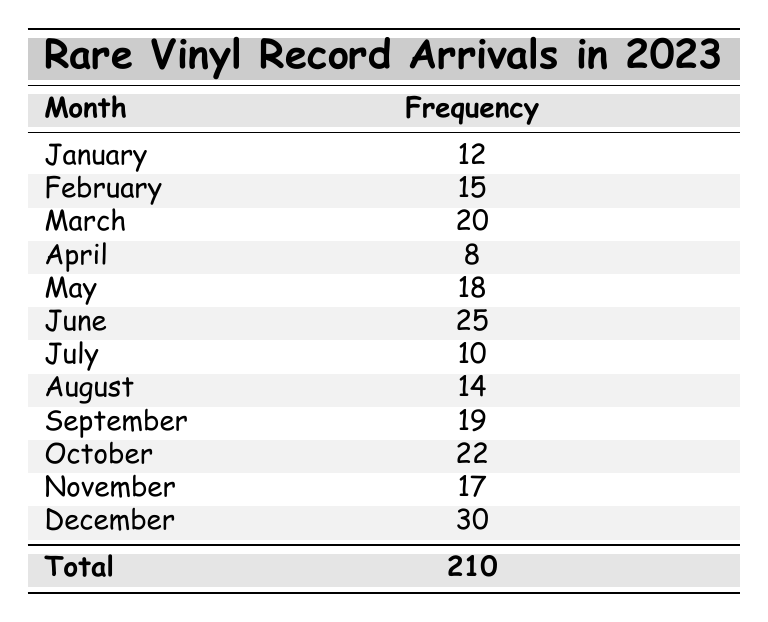What is the total number of rare vinyl records that arrived in 2023? To find the total number of rare vinyl records that arrived, we need to sum all the monthly arrivals from January to December. The arrivals are: 12 + 15 + 20 + 8 + 18 + 25 + 10 + 14 + 19 + 22 + 17 + 30, which equals 210.
Answer: 210 Which month had the highest number of arrivals? By reviewing the arrivals for each month, December shows the highest number with 30 records.
Answer: December How many months had more than 15 arrivals? We can identify the months: February (15), March (20), May (18), June (25), September (19), October (22), November (17), and December (30). Counting these gives us 7 months.
Answer: 7 What is the average number of rare vinyl records that arrived per month in 2023? The total arrivals are 210. To find the average, divide this by the 12 months: 210 / 12 = 17.5.
Answer: 17.5 Did more records arrive in June than in both March and April combined? March had 20 and April had 8, so together they total 28. June had 25 arrivals, which is less than 28. Therefore, the answer is no.
Answer: No What is the difference between the month with the largest and smallest arrivals? The largest arrival was in December with 30 records, and the smallest was in April with 8 records. The difference is 30 - 8 = 22.
Answer: 22 Which month had 10 arrivals? Looking at the data, the month with 10 arrivals is July.
Answer: July How many months had fewer than 15 arrivals? The months with fewer than 15 arrivals are January (12), April (8), July (10), and August (14). This gives us 4 months.
Answer: 4 What is the median number of arrivals for the year? Arranging the monthly arrivals in order: 8, 10, 12, 14, 15, 17, 18, 19, 20, 22, 25, 30. Since there are 12 months, the median is the average of the 6th and 7th values: (17 + 18) / 2 = 17.5.
Answer: 17.5 